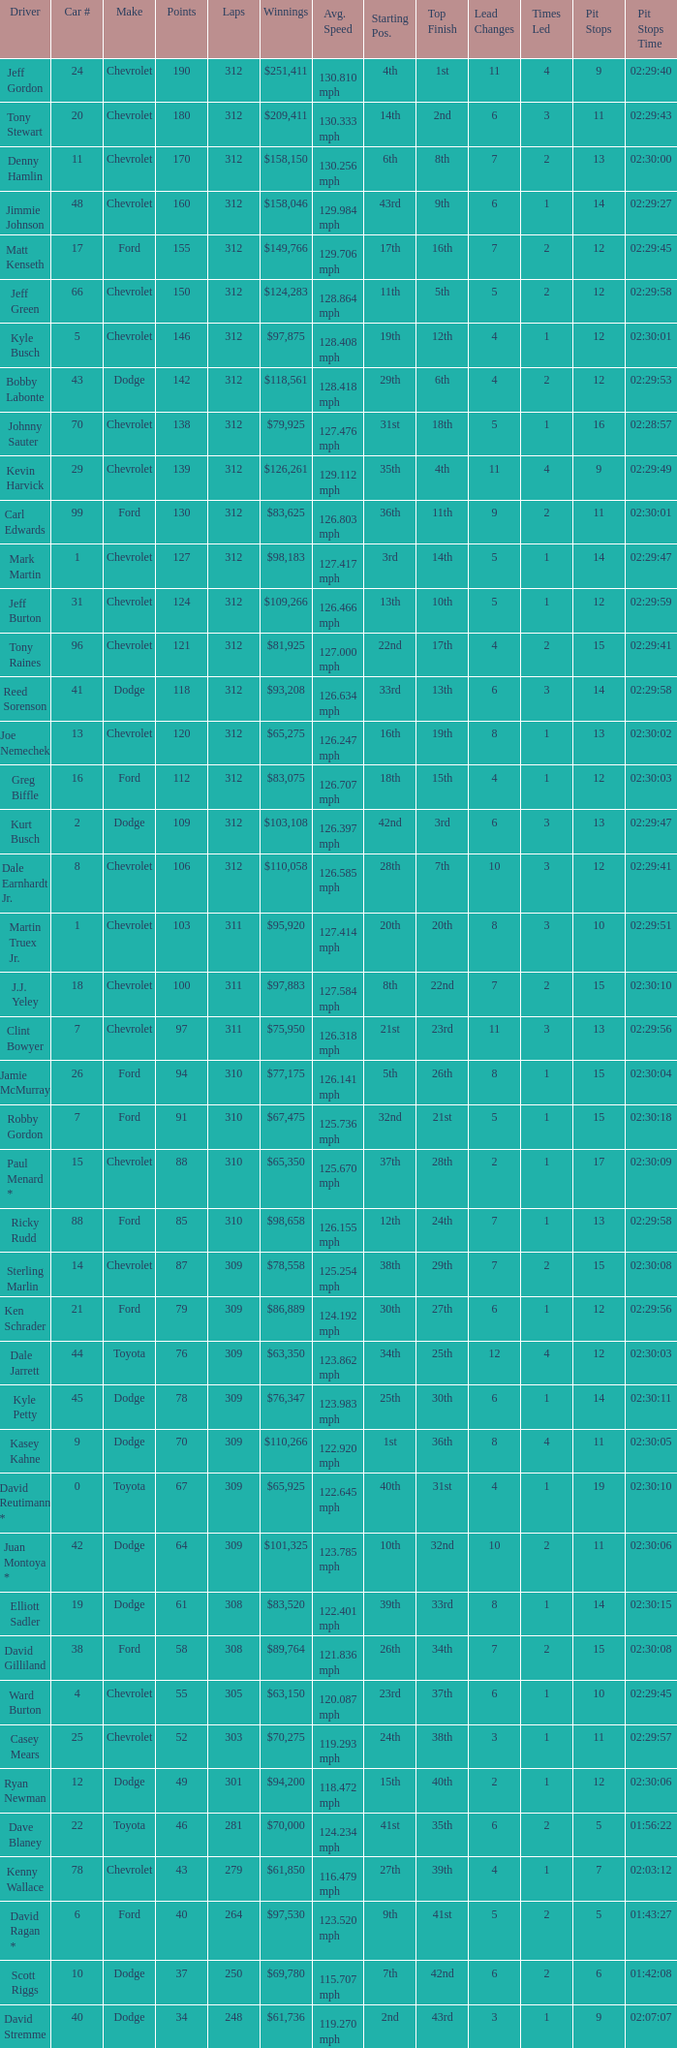What is the sum of laps that has a car number of larger than 1, is a ford, and has 155 points? 312.0. 